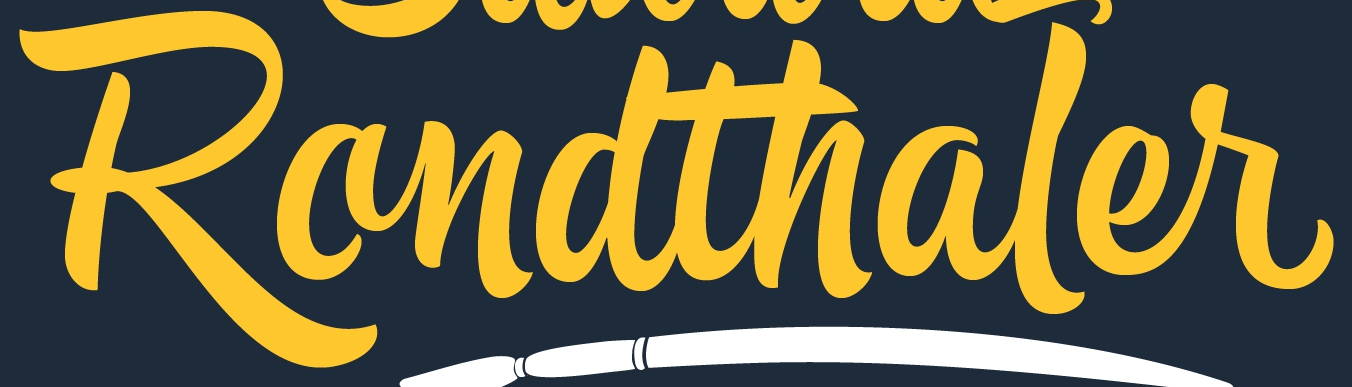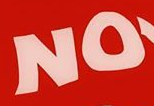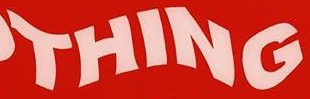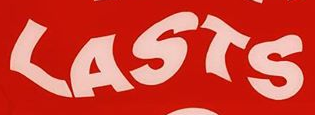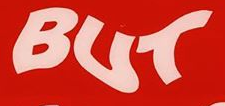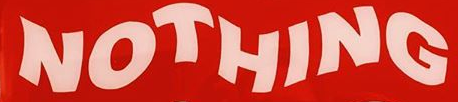What words are shown in these images in order, separated by a semicolon? Randthaler; NO; THING; LASTS; BUT; NOTHING 